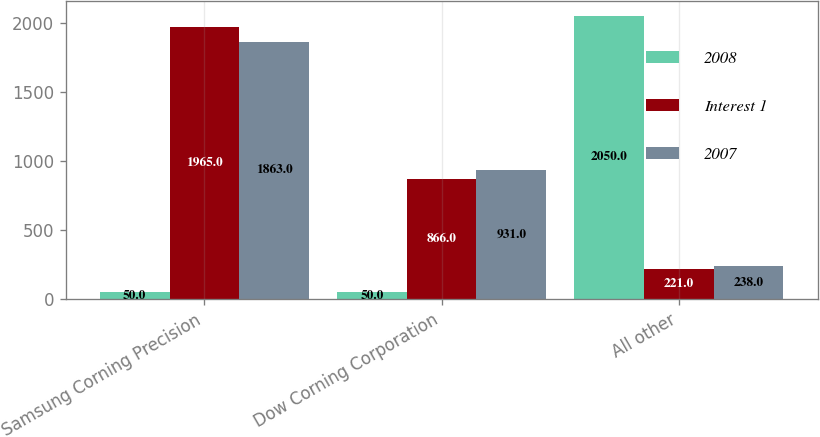<chart> <loc_0><loc_0><loc_500><loc_500><stacked_bar_chart><ecel><fcel>Samsung Corning Precision<fcel>Dow Corning Corporation<fcel>All other<nl><fcel>2008<fcel>50<fcel>50<fcel>2050<nl><fcel>Interest 1<fcel>1965<fcel>866<fcel>221<nl><fcel>2007<fcel>1863<fcel>931<fcel>238<nl></chart> 